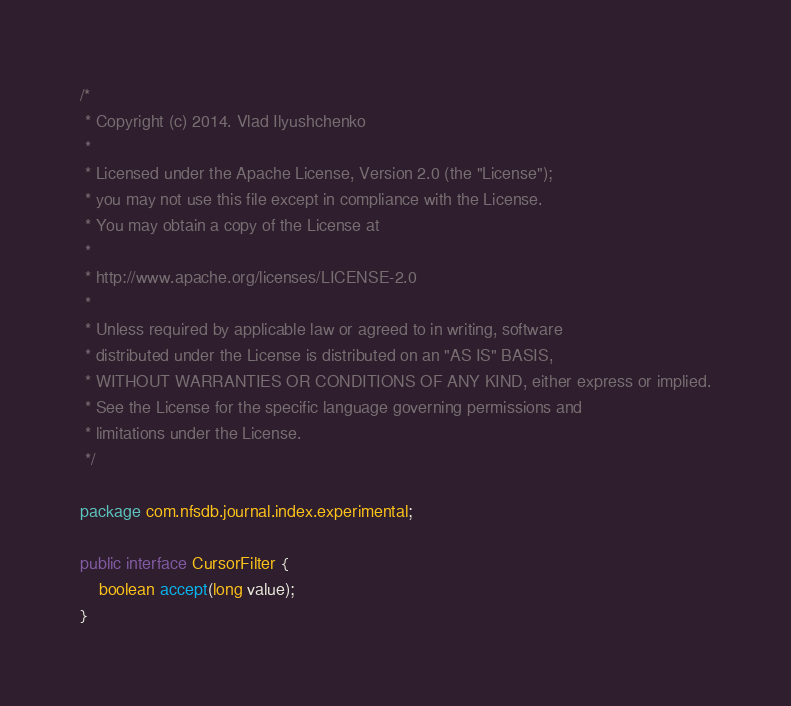<code> <loc_0><loc_0><loc_500><loc_500><_Java_>/*
 * Copyright (c) 2014. Vlad Ilyushchenko
 *
 * Licensed under the Apache License, Version 2.0 (the "License");
 * you may not use this file except in compliance with the License.
 * You may obtain a copy of the License at
 *
 * http://www.apache.org/licenses/LICENSE-2.0
 *
 * Unless required by applicable law or agreed to in writing, software
 * distributed under the License is distributed on an "AS IS" BASIS,
 * WITHOUT WARRANTIES OR CONDITIONS OF ANY KIND, either express or implied.
 * See the License for the specific language governing permissions and
 * limitations under the License.
 */

package com.nfsdb.journal.index.experimental;

public interface CursorFilter {
    boolean accept(long value);
}
</code> 